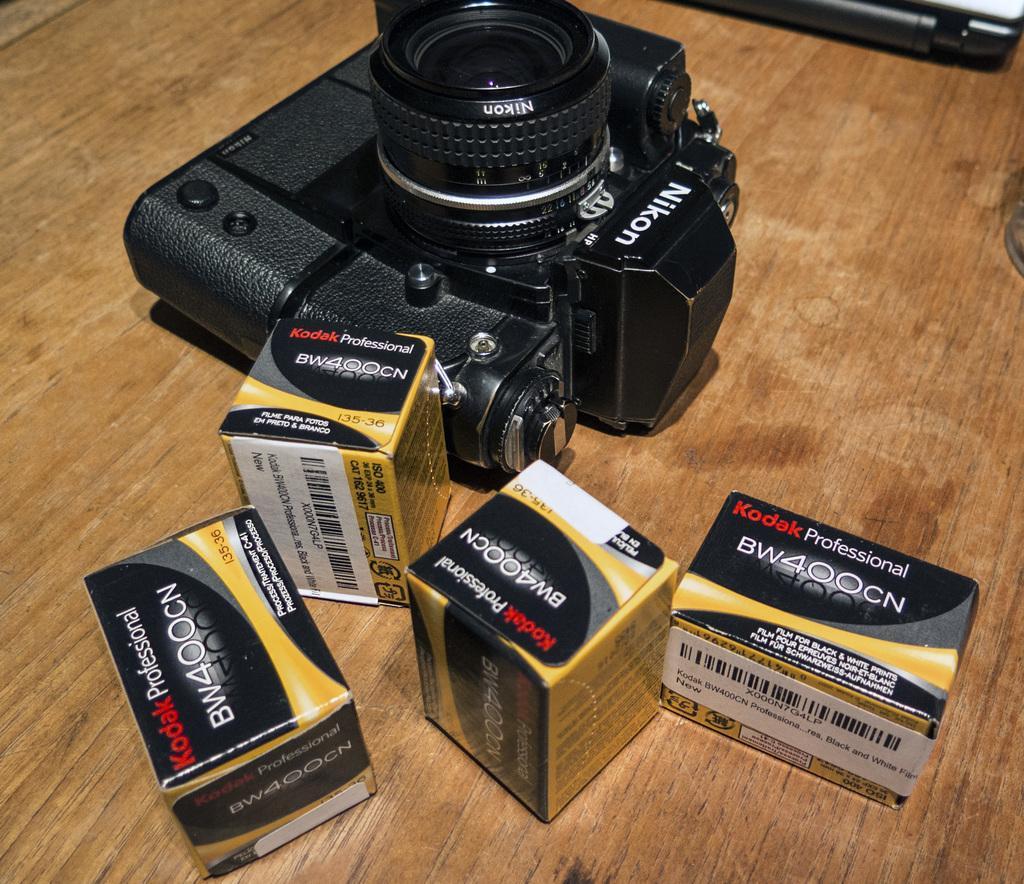Can you describe this image briefly? In this picture I can see the brown color surface in front and I can see 4 boxes and a camera and I see something is written on these things. On the top right of this picture I can see a grey color thing. 